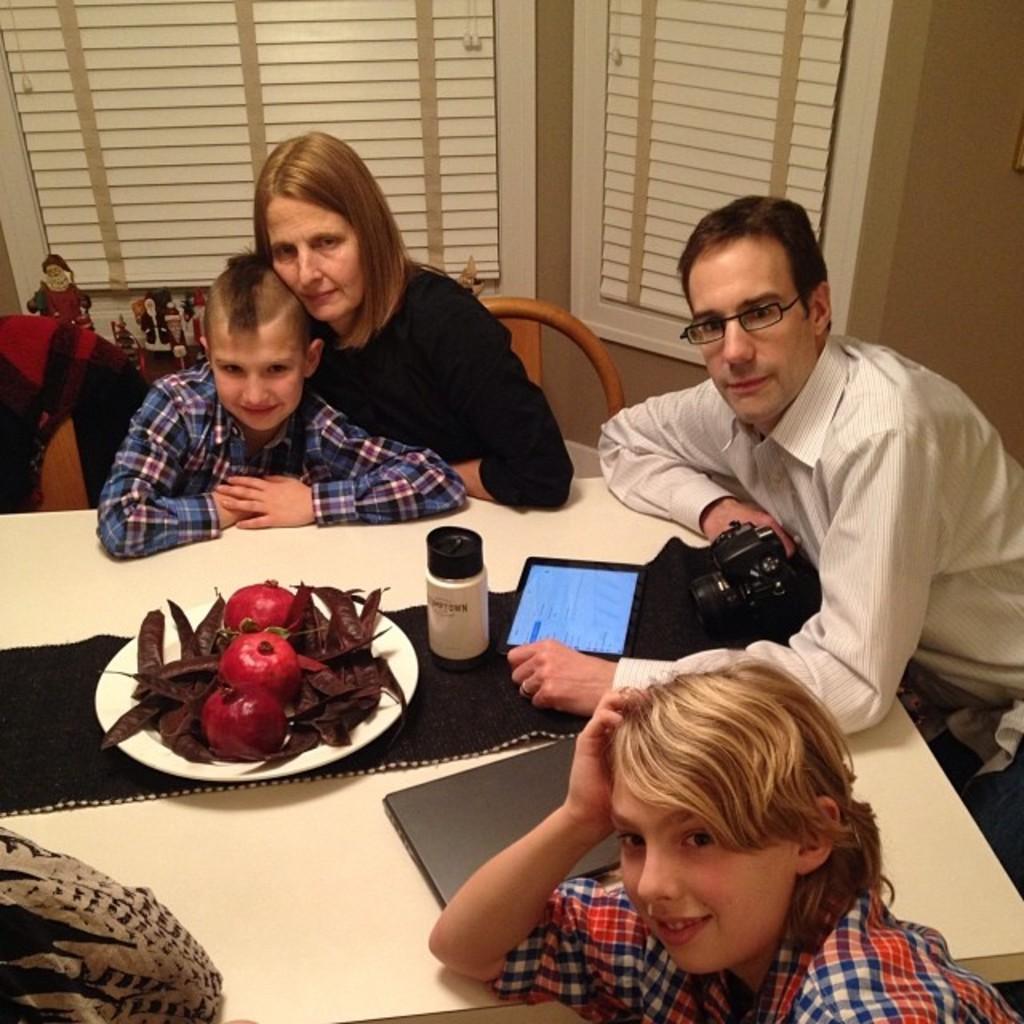Can you describe this image briefly? This picture describes about group of people, a man is seated on the chair and he is holding a camera in his hand, in front of them we can find a plate, bottle, a laptop on top of the table. 